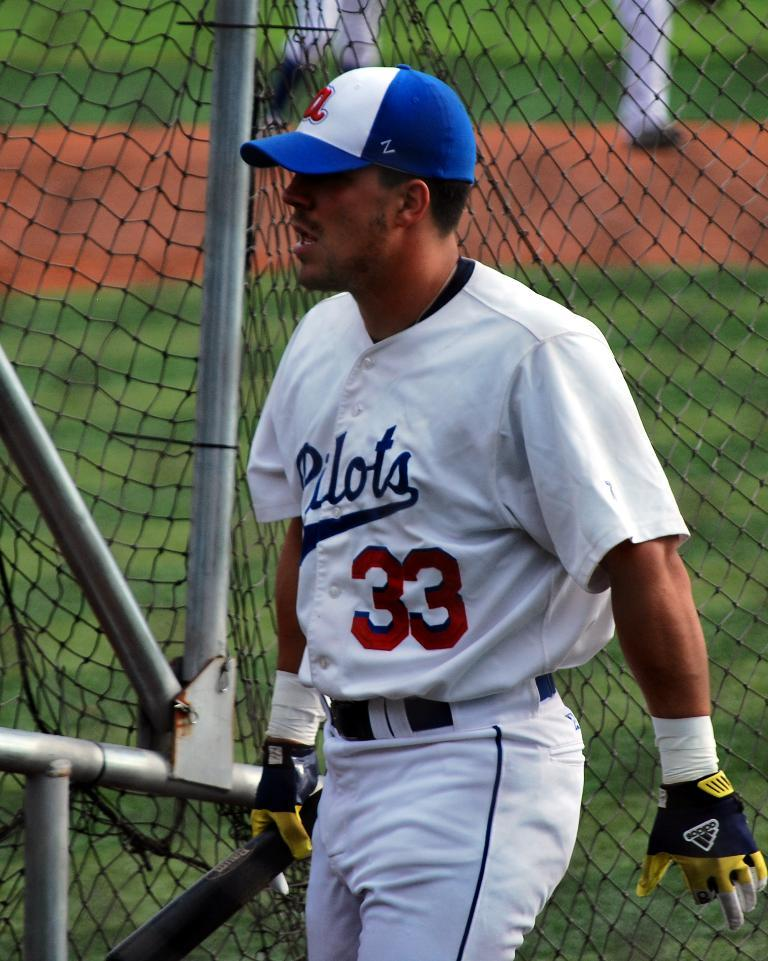<image>
Provide a brief description of the given image. A sportsman with the number 33 on his shirt. 